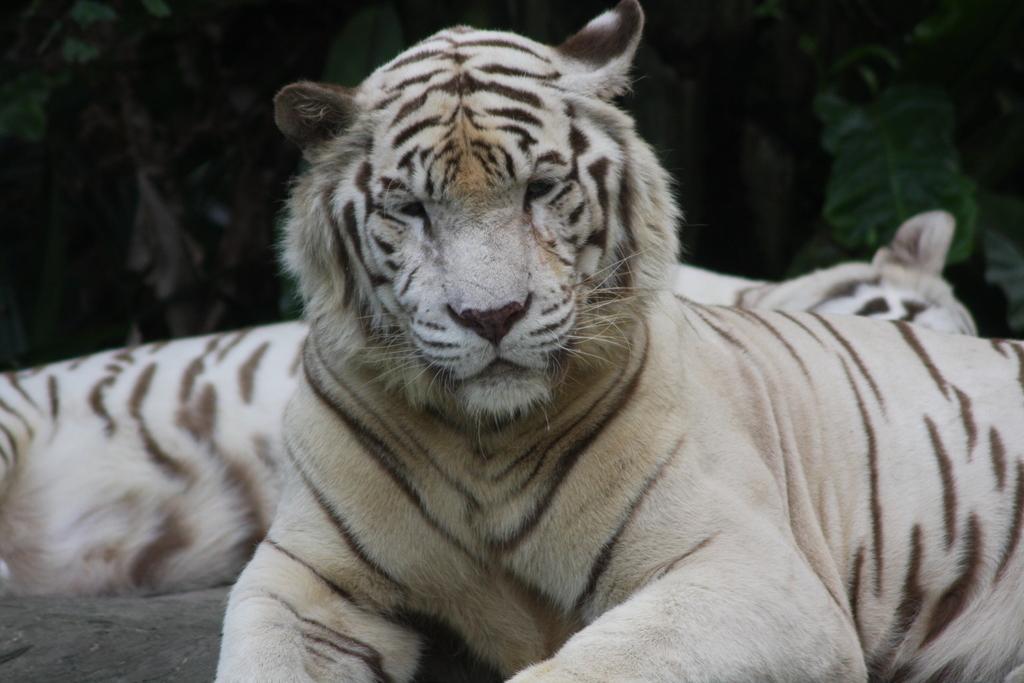How would you summarize this image in a sentence or two? In This image in the center there are two tigers, and in the background there are trees. 